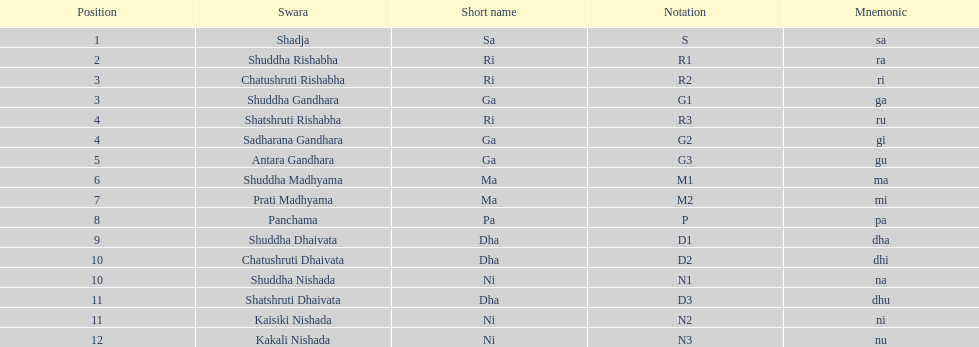What swara is above shatshruti dhaivata? Shuddha Nishada. 